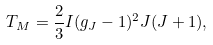<formula> <loc_0><loc_0><loc_500><loc_500>T _ { M } = \frac { 2 } { 3 } I ( g _ { J } - 1 ) ^ { 2 } J ( J + 1 ) ,</formula> 